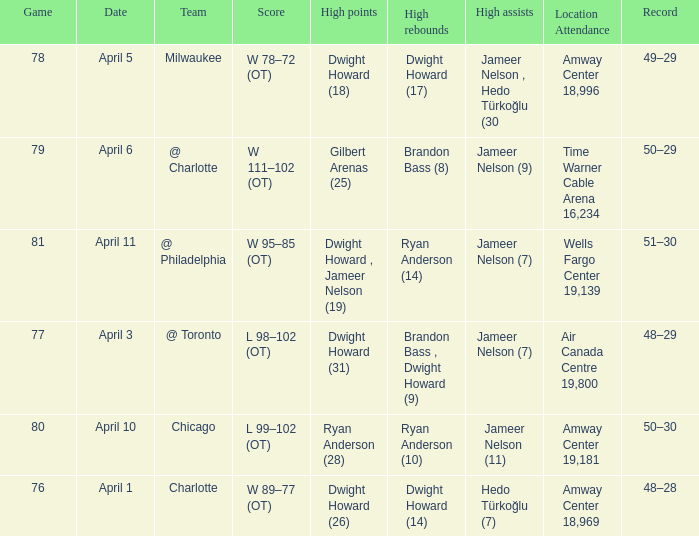Where was the game and what was the attendance on April 3?  Air Canada Centre 19,800. 